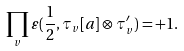<formula> <loc_0><loc_0><loc_500><loc_500>\prod _ { v } \varepsilon ( \frac { 1 } { 2 } , \tau _ { v } [ a ] \otimes \tau ^ { \prime } _ { v } ) = + 1 .</formula> 